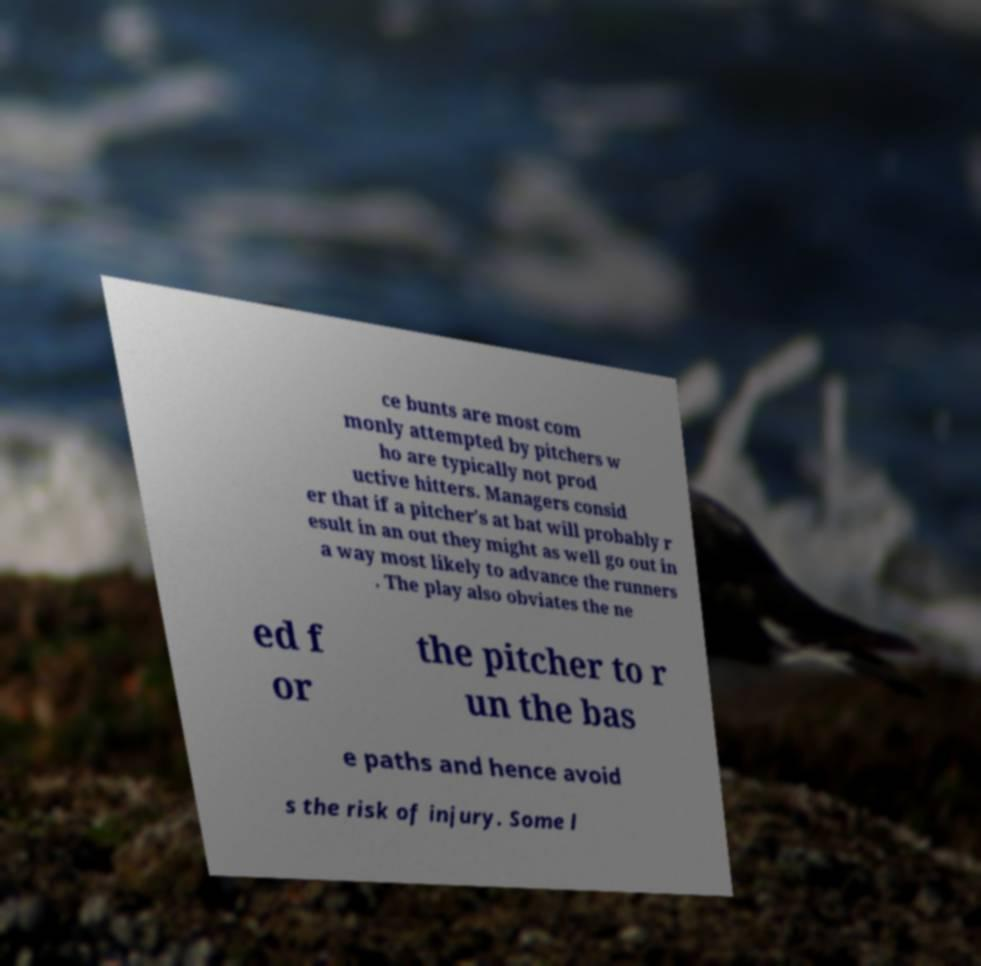Can you read and provide the text displayed in the image?This photo seems to have some interesting text. Can you extract and type it out for me? ce bunts are most com monly attempted by pitchers w ho are typically not prod uctive hitters. Managers consid er that if a pitcher's at bat will probably r esult in an out they might as well go out in a way most likely to advance the runners . The play also obviates the ne ed f or the pitcher to r un the bas e paths and hence avoid s the risk of injury. Some l 